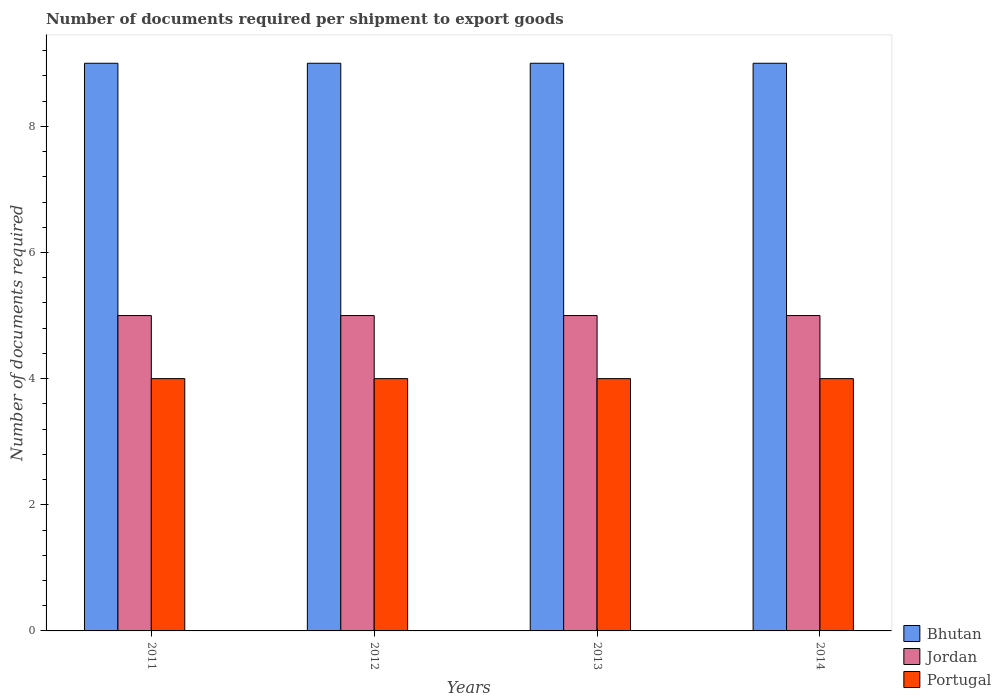How many groups of bars are there?
Ensure brevity in your answer.  4. Are the number of bars on each tick of the X-axis equal?
Give a very brief answer. Yes. How many bars are there on the 1st tick from the left?
Offer a terse response. 3. How many bars are there on the 1st tick from the right?
Your answer should be compact. 3. What is the number of documents required per shipment to export goods in Bhutan in 2014?
Your response must be concise. 9. Across all years, what is the maximum number of documents required per shipment to export goods in Jordan?
Your response must be concise. 5. Across all years, what is the minimum number of documents required per shipment to export goods in Jordan?
Ensure brevity in your answer.  5. In which year was the number of documents required per shipment to export goods in Jordan maximum?
Your answer should be very brief. 2011. In which year was the number of documents required per shipment to export goods in Portugal minimum?
Your answer should be compact. 2011. What is the total number of documents required per shipment to export goods in Jordan in the graph?
Your answer should be very brief. 20. What is the difference between the number of documents required per shipment to export goods in Jordan in 2014 and the number of documents required per shipment to export goods in Bhutan in 2013?
Give a very brief answer. -4. In the year 2011, what is the difference between the number of documents required per shipment to export goods in Jordan and number of documents required per shipment to export goods in Portugal?
Offer a very short reply. 1. In how many years, is the number of documents required per shipment to export goods in Portugal greater than 8?
Provide a short and direct response. 0. What is the difference between the highest and the second highest number of documents required per shipment to export goods in Portugal?
Give a very brief answer. 0. What is the difference between the highest and the lowest number of documents required per shipment to export goods in Portugal?
Your answer should be very brief. 0. In how many years, is the number of documents required per shipment to export goods in Bhutan greater than the average number of documents required per shipment to export goods in Bhutan taken over all years?
Offer a terse response. 0. What does the 3rd bar from the right in 2014 represents?
Your answer should be compact. Bhutan. How many bars are there?
Keep it short and to the point. 12. Are all the bars in the graph horizontal?
Your response must be concise. No. What is the difference between two consecutive major ticks on the Y-axis?
Offer a terse response. 2. Where does the legend appear in the graph?
Offer a very short reply. Bottom right. How are the legend labels stacked?
Provide a succinct answer. Vertical. What is the title of the graph?
Provide a short and direct response. Number of documents required per shipment to export goods. What is the label or title of the Y-axis?
Ensure brevity in your answer.  Number of documents required. What is the Number of documents required in Jordan in 2011?
Offer a very short reply. 5. What is the Number of documents required of Portugal in 2011?
Your response must be concise. 4. What is the Number of documents required of Bhutan in 2012?
Give a very brief answer. 9. What is the Number of documents required of Portugal in 2012?
Your response must be concise. 4. What is the Number of documents required of Jordan in 2013?
Offer a very short reply. 5. What is the Number of documents required of Portugal in 2013?
Offer a terse response. 4. What is the Number of documents required in Bhutan in 2014?
Your answer should be very brief. 9. What is the Number of documents required in Jordan in 2014?
Keep it short and to the point. 5. What is the Number of documents required of Portugal in 2014?
Offer a terse response. 4. Across all years, what is the maximum Number of documents required in Jordan?
Keep it short and to the point. 5. Across all years, what is the minimum Number of documents required in Bhutan?
Give a very brief answer. 9. Across all years, what is the minimum Number of documents required in Portugal?
Your answer should be very brief. 4. What is the difference between the Number of documents required in Bhutan in 2011 and that in 2012?
Offer a terse response. 0. What is the difference between the Number of documents required in Portugal in 2011 and that in 2013?
Keep it short and to the point. 0. What is the difference between the Number of documents required of Jordan in 2012 and that in 2014?
Keep it short and to the point. 0. What is the difference between the Number of documents required of Bhutan in 2013 and that in 2014?
Give a very brief answer. 0. What is the difference between the Number of documents required in Bhutan in 2011 and the Number of documents required in Jordan in 2012?
Your answer should be very brief. 4. What is the difference between the Number of documents required in Bhutan in 2011 and the Number of documents required in Jordan in 2013?
Your answer should be very brief. 4. What is the difference between the Number of documents required of Bhutan in 2011 and the Number of documents required of Portugal in 2013?
Provide a short and direct response. 5. What is the difference between the Number of documents required of Jordan in 2011 and the Number of documents required of Portugal in 2013?
Make the answer very short. 1. What is the difference between the Number of documents required of Bhutan in 2011 and the Number of documents required of Portugal in 2014?
Provide a short and direct response. 5. What is the difference between the Number of documents required of Jordan in 2011 and the Number of documents required of Portugal in 2014?
Offer a terse response. 1. What is the difference between the Number of documents required in Bhutan in 2012 and the Number of documents required in Jordan in 2013?
Your answer should be very brief. 4. What is the difference between the Number of documents required in Bhutan in 2012 and the Number of documents required in Portugal in 2013?
Your response must be concise. 5. What is the difference between the Number of documents required of Bhutan in 2012 and the Number of documents required of Jordan in 2014?
Make the answer very short. 4. What is the difference between the Number of documents required in Jordan in 2012 and the Number of documents required in Portugal in 2014?
Make the answer very short. 1. What is the difference between the Number of documents required in Bhutan in 2013 and the Number of documents required in Jordan in 2014?
Keep it short and to the point. 4. What is the difference between the Number of documents required of Bhutan in 2013 and the Number of documents required of Portugal in 2014?
Provide a succinct answer. 5. In the year 2011, what is the difference between the Number of documents required in Bhutan and Number of documents required in Portugal?
Keep it short and to the point. 5. In the year 2011, what is the difference between the Number of documents required in Jordan and Number of documents required in Portugal?
Offer a very short reply. 1. In the year 2012, what is the difference between the Number of documents required of Bhutan and Number of documents required of Jordan?
Give a very brief answer. 4. In the year 2012, what is the difference between the Number of documents required in Bhutan and Number of documents required in Portugal?
Provide a succinct answer. 5. In the year 2012, what is the difference between the Number of documents required in Jordan and Number of documents required in Portugal?
Your response must be concise. 1. In the year 2013, what is the difference between the Number of documents required of Jordan and Number of documents required of Portugal?
Keep it short and to the point. 1. In the year 2014, what is the difference between the Number of documents required in Jordan and Number of documents required in Portugal?
Make the answer very short. 1. What is the ratio of the Number of documents required of Jordan in 2011 to that in 2012?
Make the answer very short. 1. What is the ratio of the Number of documents required of Portugal in 2011 to that in 2012?
Offer a very short reply. 1. What is the ratio of the Number of documents required in Jordan in 2011 to that in 2013?
Your answer should be compact. 1. What is the ratio of the Number of documents required of Jordan in 2011 to that in 2014?
Make the answer very short. 1. What is the ratio of the Number of documents required in Portugal in 2011 to that in 2014?
Your answer should be very brief. 1. What is the ratio of the Number of documents required in Bhutan in 2012 to that in 2013?
Provide a succinct answer. 1. What is the ratio of the Number of documents required in Portugal in 2012 to that in 2013?
Offer a very short reply. 1. What is the ratio of the Number of documents required in Bhutan in 2012 to that in 2014?
Your answer should be compact. 1. What is the ratio of the Number of documents required in Jordan in 2012 to that in 2014?
Provide a short and direct response. 1. What is the ratio of the Number of documents required of Jordan in 2013 to that in 2014?
Offer a terse response. 1. What is the difference between the highest and the second highest Number of documents required of Bhutan?
Offer a very short reply. 0. What is the difference between the highest and the lowest Number of documents required of Jordan?
Your response must be concise. 0. 